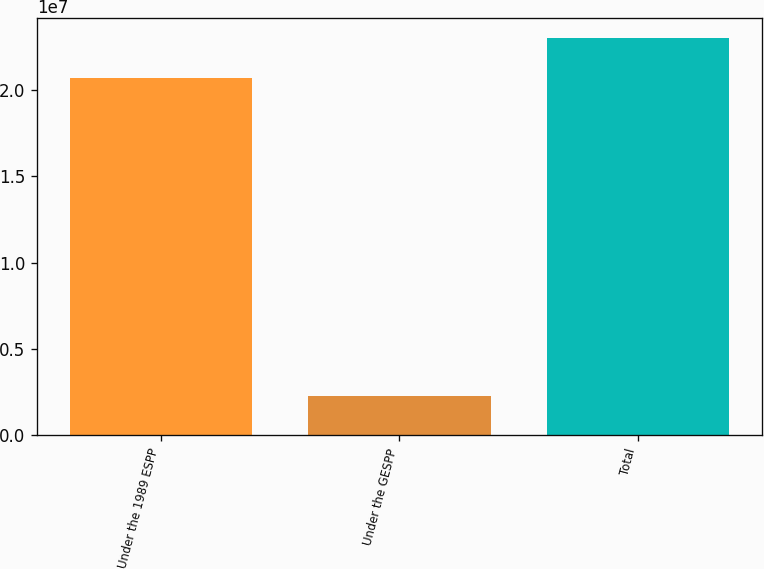Convert chart. <chart><loc_0><loc_0><loc_500><loc_500><bar_chart><fcel>Under the 1989 ESPP<fcel>Under the GESPP<fcel>Total<nl><fcel>2.06859e+07<fcel>2.30714e+06<fcel>2.2993e+07<nl></chart> 